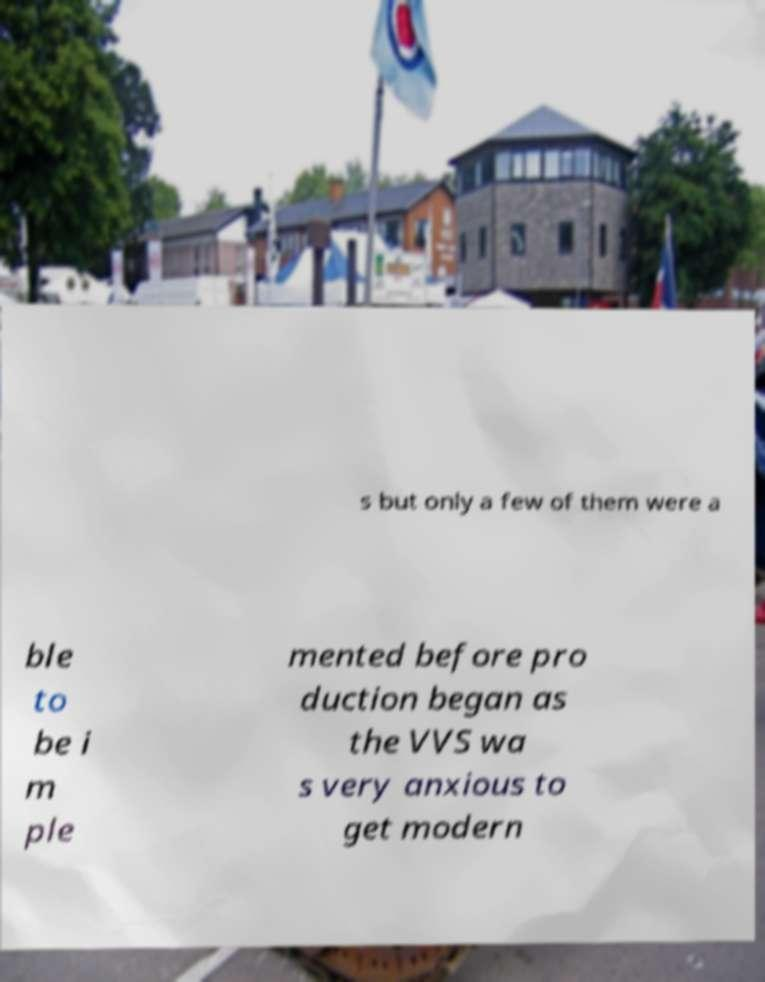Please identify and transcribe the text found in this image. s but only a few of them were a ble to be i m ple mented before pro duction began as the VVS wa s very anxious to get modern 